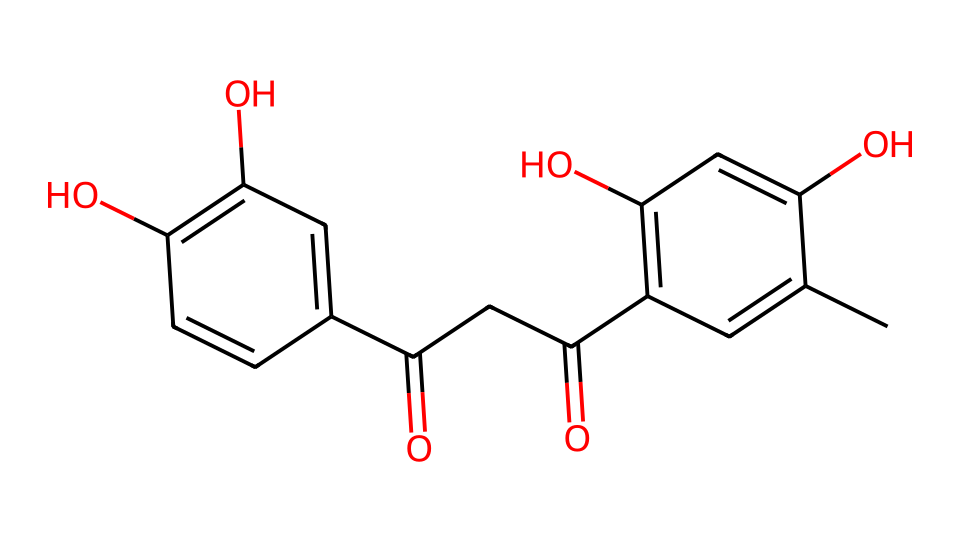What is the main functional group present in curcumin? The chemical structure of curcumin showcases hydroxyl groups (indicated by 'O' attached to carbon) and a carbonyl group (C=O) within its framework. The presence of -OH groups indicates the main functional group.
Answer: phenol How many carbon atoms are present in the molecular structure? By analyzing the SMILES, I count the carbon atoms represented in the structure, including each 'C' and those part of the aromatic rings. There are a total of 21 carbon atoms in curcumin.
Answer: 21 What is the total number of double bonds in curcumin? In the SMILES, I count the double bonds represented between carbon atoms (C=C) in the aromatic rings as well as any C=O bonds. There are 6 double bonds in total.
Answer: 6 Does curcumin contain aromatic rings? The convertible sections of the SMILES, particularly the sequences with alternating double bonds (C=C), indicate the presence of aromatic structures. Therefore, it is confirmed that curcumin has aromatic rings.
Answer: yes What type of binding does curcumin engage in with other substances when used as a coloring agent? The numerous hydroxyl groups exhibited in the structure allow curcumin to form hydrogen bonds with other substances, enhancing its solubility and interaction as a coloring agent.
Answer: hydrogen bonding 